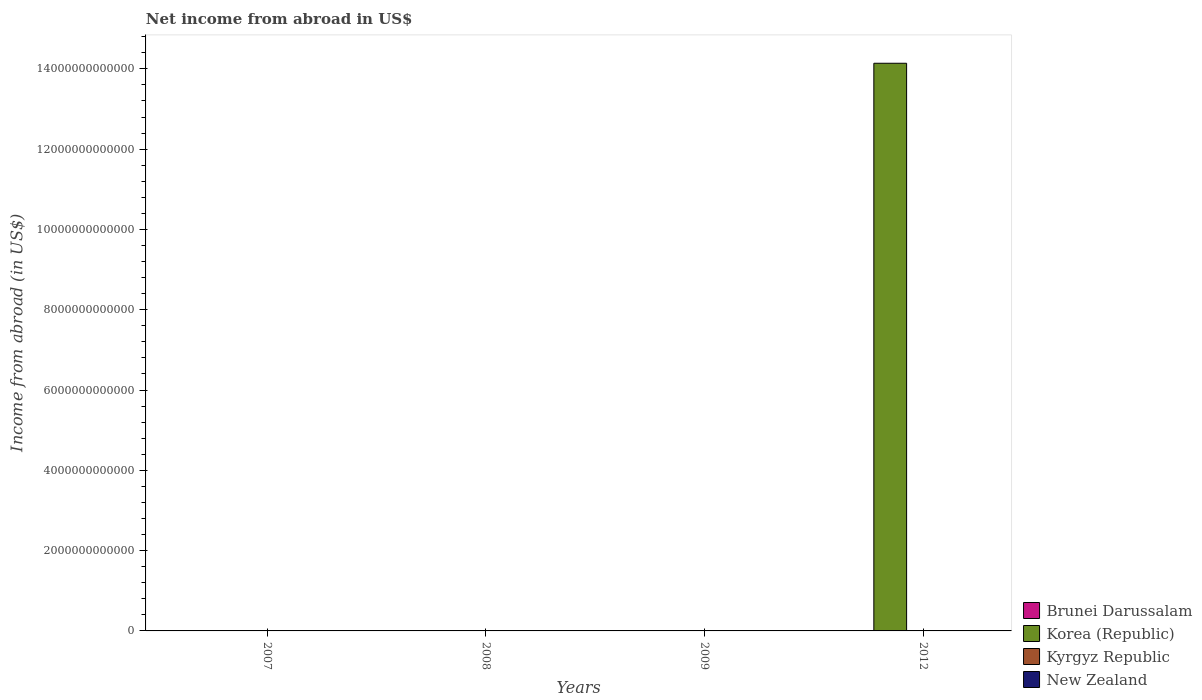Are the number of bars per tick equal to the number of legend labels?
Keep it short and to the point. No. Are the number of bars on each tick of the X-axis equal?
Provide a succinct answer. Yes. How many bars are there on the 4th tick from the left?
Offer a very short reply. 1. Across all years, what is the maximum net income from abroad in Korea (Republic)?
Offer a very short reply. 1.41e+13. Across all years, what is the minimum net income from abroad in New Zealand?
Make the answer very short. 0. In which year was the net income from abroad in Brunei Darussalam maximum?
Provide a succinct answer. 2007. What is the total net income from abroad in Brunei Darussalam in the graph?
Make the answer very short. 2.47e+08. What is the difference between the net income from abroad in Brunei Darussalam in 2007 and that in 2009?
Your response must be concise. 1.83e+07. What is the difference between the net income from abroad in Brunei Darussalam in 2008 and the net income from abroad in Korea (Republic) in 2009?
Offer a terse response. 7.72e+07. In how many years, is the net income from abroad in New Zealand greater than 1600000000000 US$?
Ensure brevity in your answer.  0. What is the ratio of the net income from abroad in Brunei Darussalam in 2007 to that in 2008?
Ensure brevity in your answer.  1.22. What is the difference between the highest and the lowest net income from abroad in Brunei Darussalam?
Your response must be concise. 9.40e+07. Is it the case that in every year, the sum of the net income from abroad in Korea (Republic) and net income from abroad in New Zealand is greater than the net income from abroad in Brunei Darussalam?
Offer a very short reply. No. How many bars are there?
Offer a terse response. 4. Are all the bars in the graph horizontal?
Give a very brief answer. No. How many years are there in the graph?
Make the answer very short. 4. What is the difference between two consecutive major ticks on the Y-axis?
Offer a very short reply. 2.00e+12. Are the values on the major ticks of Y-axis written in scientific E-notation?
Ensure brevity in your answer.  No. Where does the legend appear in the graph?
Ensure brevity in your answer.  Bottom right. How many legend labels are there?
Provide a succinct answer. 4. What is the title of the graph?
Ensure brevity in your answer.  Net income from abroad in US$. Does "Sierra Leone" appear as one of the legend labels in the graph?
Offer a terse response. No. What is the label or title of the X-axis?
Keep it short and to the point. Years. What is the label or title of the Y-axis?
Offer a terse response. Income from abroad (in US$). What is the Income from abroad (in US$) in Brunei Darussalam in 2007?
Provide a succinct answer. 9.40e+07. What is the Income from abroad (in US$) of Korea (Republic) in 2007?
Your answer should be compact. 0. What is the Income from abroad (in US$) of Brunei Darussalam in 2008?
Your response must be concise. 7.72e+07. What is the Income from abroad (in US$) in Korea (Republic) in 2008?
Provide a succinct answer. 0. What is the Income from abroad (in US$) in Kyrgyz Republic in 2008?
Your response must be concise. 0. What is the Income from abroad (in US$) of New Zealand in 2008?
Offer a terse response. 0. What is the Income from abroad (in US$) of Brunei Darussalam in 2009?
Your response must be concise. 7.58e+07. What is the Income from abroad (in US$) of New Zealand in 2009?
Make the answer very short. 0. What is the Income from abroad (in US$) in Brunei Darussalam in 2012?
Offer a very short reply. 0. What is the Income from abroad (in US$) in Korea (Republic) in 2012?
Provide a short and direct response. 1.41e+13. What is the Income from abroad (in US$) in Kyrgyz Republic in 2012?
Provide a short and direct response. 0. Across all years, what is the maximum Income from abroad (in US$) in Brunei Darussalam?
Your answer should be compact. 9.40e+07. Across all years, what is the maximum Income from abroad (in US$) of Korea (Republic)?
Keep it short and to the point. 1.41e+13. What is the total Income from abroad (in US$) in Brunei Darussalam in the graph?
Your response must be concise. 2.47e+08. What is the total Income from abroad (in US$) in Korea (Republic) in the graph?
Make the answer very short. 1.41e+13. What is the total Income from abroad (in US$) of Kyrgyz Republic in the graph?
Your response must be concise. 0. What is the difference between the Income from abroad (in US$) of Brunei Darussalam in 2007 and that in 2008?
Make the answer very short. 1.68e+07. What is the difference between the Income from abroad (in US$) in Brunei Darussalam in 2007 and that in 2009?
Your response must be concise. 1.83e+07. What is the difference between the Income from abroad (in US$) of Brunei Darussalam in 2008 and that in 2009?
Keep it short and to the point. 1.45e+06. What is the difference between the Income from abroad (in US$) of Brunei Darussalam in 2007 and the Income from abroad (in US$) of Korea (Republic) in 2012?
Ensure brevity in your answer.  -1.41e+13. What is the difference between the Income from abroad (in US$) of Brunei Darussalam in 2008 and the Income from abroad (in US$) of Korea (Republic) in 2012?
Offer a terse response. -1.41e+13. What is the difference between the Income from abroad (in US$) in Brunei Darussalam in 2009 and the Income from abroad (in US$) in Korea (Republic) in 2012?
Your response must be concise. -1.41e+13. What is the average Income from abroad (in US$) in Brunei Darussalam per year?
Your answer should be compact. 6.18e+07. What is the average Income from abroad (in US$) of Korea (Republic) per year?
Make the answer very short. 3.53e+12. What is the ratio of the Income from abroad (in US$) in Brunei Darussalam in 2007 to that in 2008?
Offer a terse response. 1.22. What is the ratio of the Income from abroad (in US$) of Brunei Darussalam in 2007 to that in 2009?
Ensure brevity in your answer.  1.24. What is the ratio of the Income from abroad (in US$) of Brunei Darussalam in 2008 to that in 2009?
Provide a succinct answer. 1.02. What is the difference between the highest and the second highest Income from abroad (in US$) in Brunei Darussalam?
Ensure brevity in your answer.  1.68e+07. What is the difference between the highest and the lowest Income from abroad (in US$) in Brunei Darussalam?
Keep it short and to the point. 9.40e+07. What is the difference between the highest and the lowest Income from abroad (in US$) in Korea (Republic)?
Ensure brevity in your answer.  1.41e+13. 